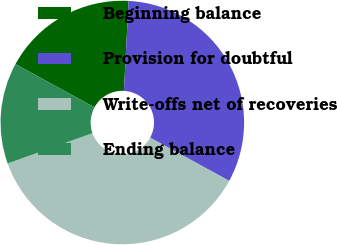Convert chart. <chart><loc_0><loc_0><loc_500><loc_500><pie_chart><fcel>Beginning balance<fcel>Provision for doubtful<fcel>Write-offs net of recoveries<fcel>Ending balance<nl><fcel>17.86%<fcel>32.14%<fcel>36.58%<fcel>13.42%<nl></chart> 